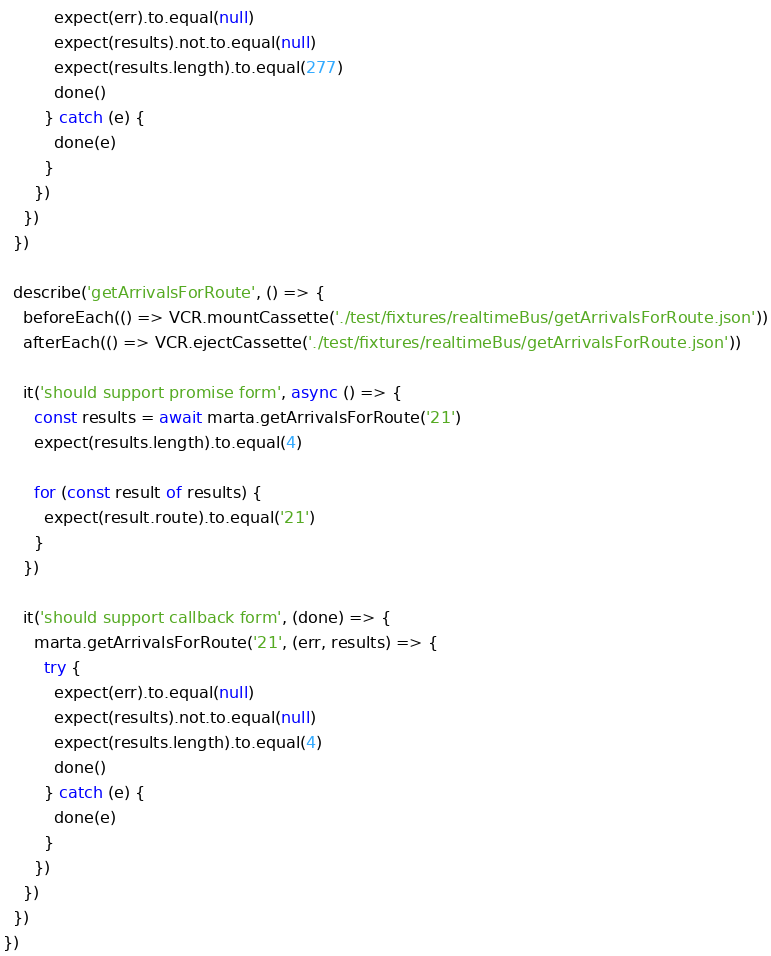Convert code to text. <code><loc_0><loc_0><loc_500><loc_500><_JavaScript_>          expect(err).to.equal(null)
          expect(results).not.to.equal(null)
          expect(results.length).to.equal(277)
          done()
        } catch (e) {
          done(e)
        }
      })
    })
  })

  describe('getArrivalsForRoute', () => {
    beforeEach(() => VCR.mountCassette('./test/fixtures/realtimeBus/getArrivalsForRoute.json'))
    afterEach(() => VCR.ejectCassette('./test/fixtures/realtimeBus/getArrivalsForRoute.json'))

    it('should support promise form', async () => {
      const results = await marta.getArrivalsForRoute('21')
      expect(results.length).to.equal(4)

      for (const result of results) {
        expect(result.route).to.equal('21')
      }
    })

    it('should support callback form', (done) => {
      marta.getArrivalsForRoute('21', (err, results) => {
        try {
          expect(err).to.equal(null)
          expect(results).not.to.equal(null)
          expect(results.length).to.equal(4)
          done()
        } catch (e) {
          done(e)
        }
      })
    })
  })
})
</code> 